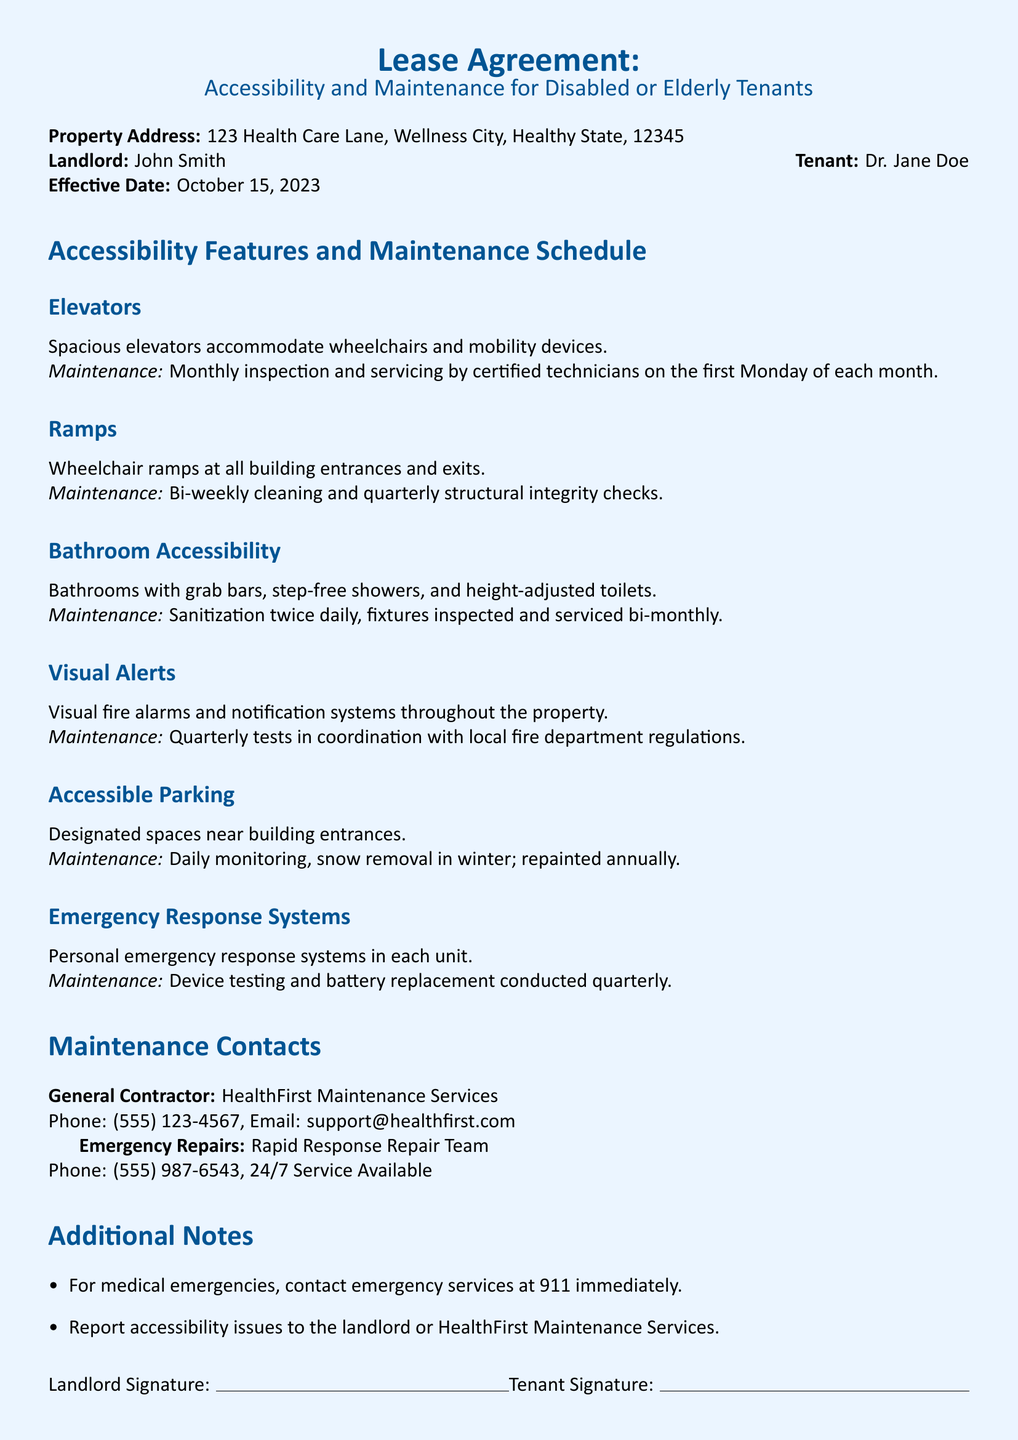What is the property address? The property address is mentioned at the beginning of the document under "Property Address."
Answer: 123 Health Care Lane, Wellness City, Healthy State, 12345 Who is the landlord? The landlord's name is listed next to "Landlord" in the document.
Answer: John Smith What feature accommodates wheelchairs and mobility devices? The document specifies "Elevators" under accessibility features.
Answer: Elevators How often are the wheelchair ramps cleaned? The maintenance schedule indicates how frequently the ramps are cleaned.
Answer: Bi-weekly What is the maintenance schedule for bathroom fixtures? The maintenance section under "Bathroom Accessibility" indicates the frequency of fixture inspections and services.
Answer: Bi-monthly When is the elevator inspection conducted? The inspection for elevators takes place on the first Monday of each month, as mentioned in the maintenance schedule.
Answer: First Monday of each month What service is available 24/7 for emergency repairs? The document mentions a specific team that offers round-the-clock service for emergency repairs.
Answer: Rapid Response Repair Team How many times are visual fire alarms tested per year? The maintenance section mentions a specific frequency for testing visual alerts.
Answer: Quarterly What are the designated parking spaces meant for? The document states the purpose of the designated parking spaces.
Answer: Accessible Parking 